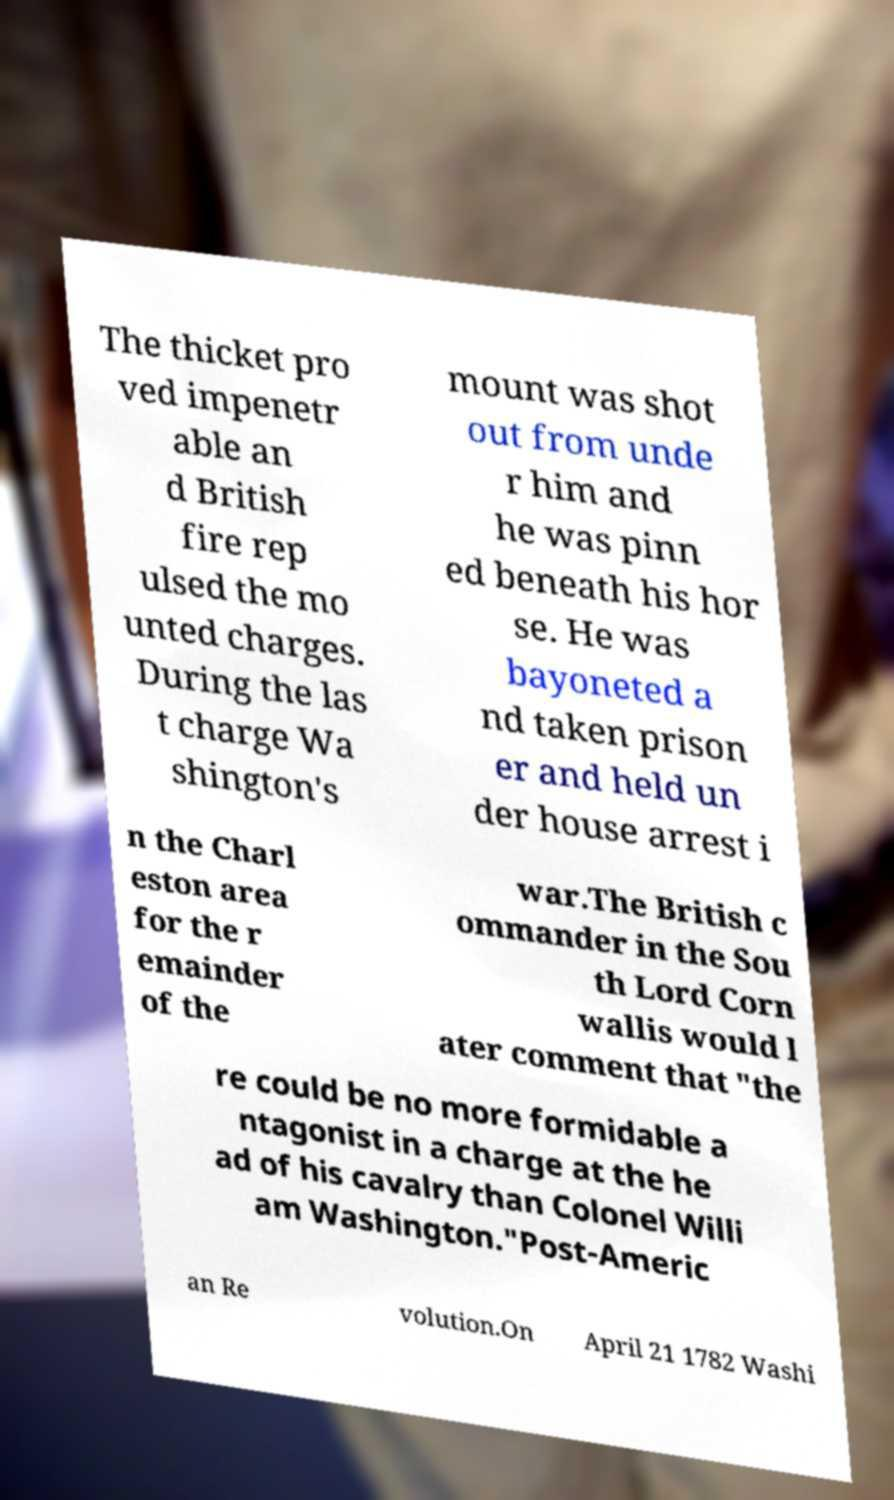What messages or text are displayed in this image? I need them in a readable, typed format. The thicket pro ved impenetr able an d British fire rep ulsed the mo unted charges. During the las t charge Wa shington's mount was shot out from unde r him and he was pinn ed beneath his hor se. He was bayoneted a nd taken prison er and held un der house arrest i n the Charl eston area for the r emainder of the war.The British c ommander in the Sou th Lord Corn wallis would l ater comment that "the re could be no more formidable a ntagonist in a charge at the he ad of his cavalry than Colonel Willi am Washington."Post-Americ an Re volution.On April 21 1782 Washi 